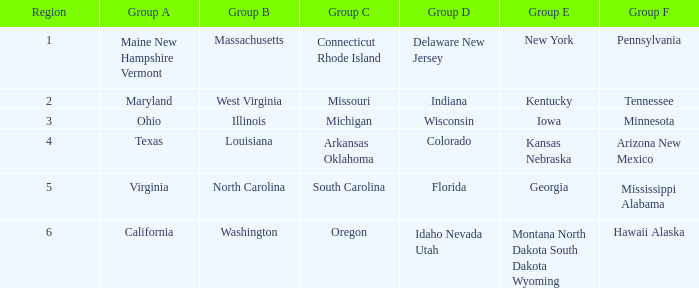What is the group b territory with a group e district in georgia? North Carolina. 